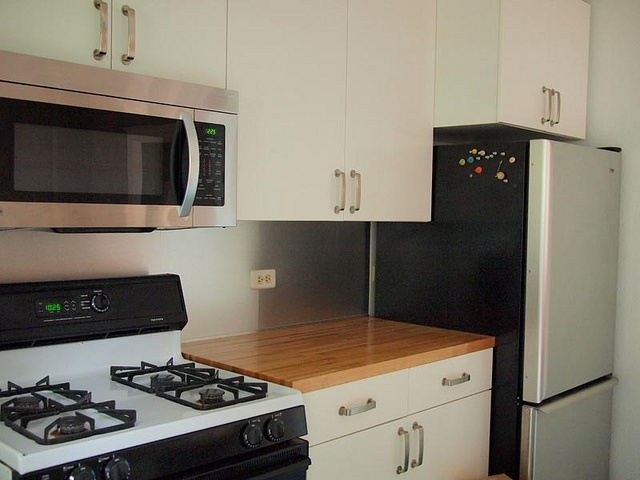Describe the objects in this image and their specific colors. I can see refrigerator in darkgray, black, and gray tones, oven in darkgray, black, gray, and lightgray tones, and microwave in darkgray, black, and gray tones in this image. 